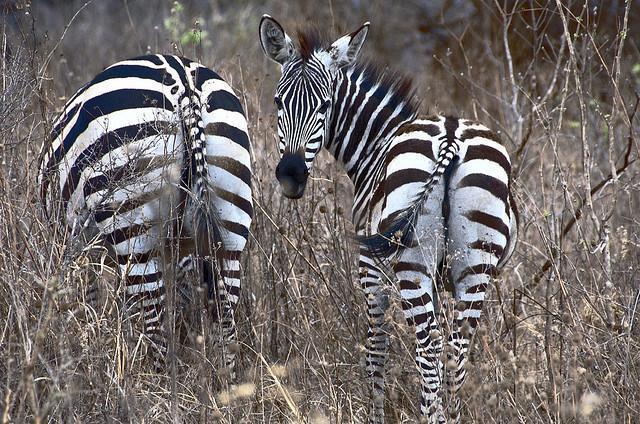How many zebras can you see?
Give a very brief answer. 2. 